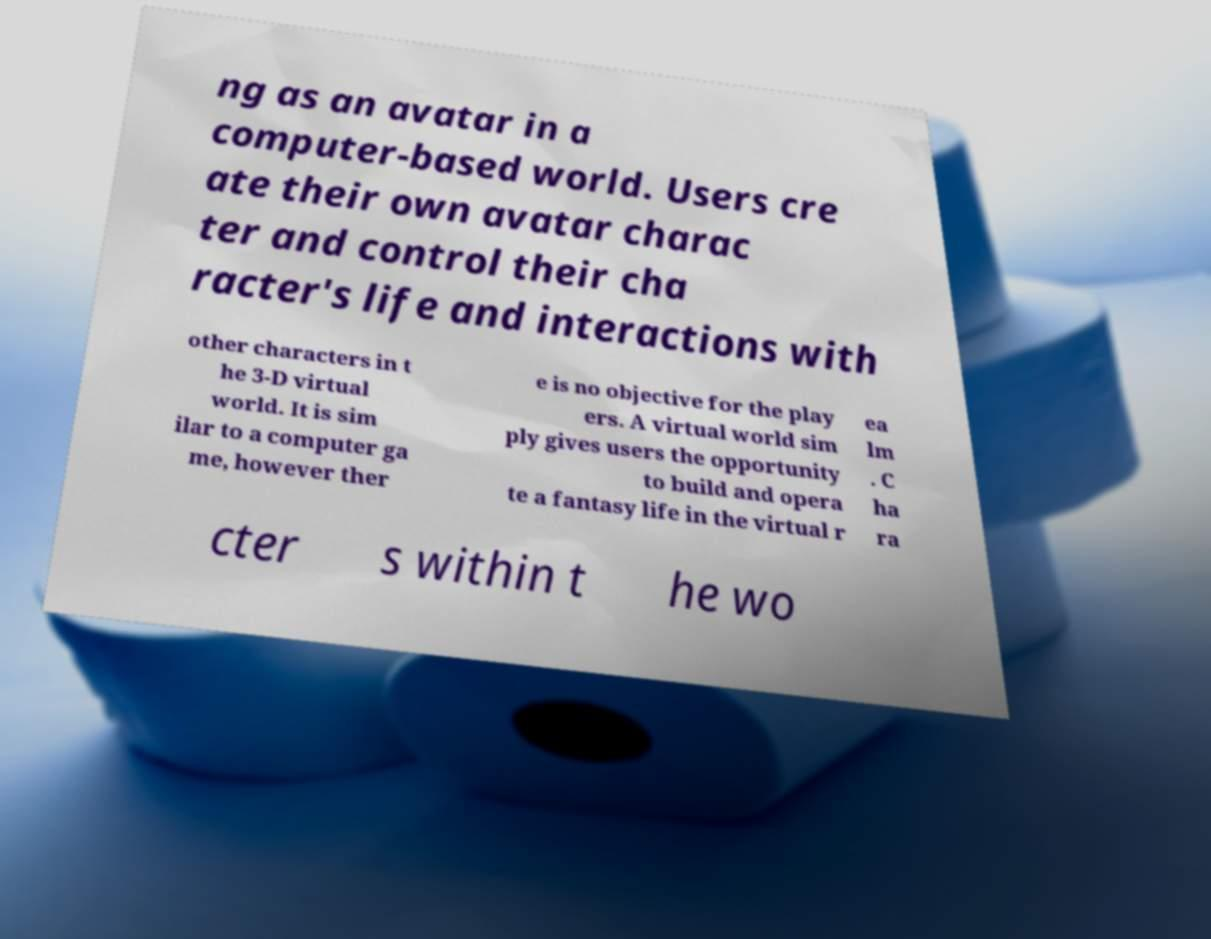Could you extract and type out the text from this image? ng as an avatar in a computer-based world. Users cre ate their own avatar charac ter and control their cha racter's life and interactions with other characters in t he 3-D virtual world. It is sim ilar to a computer ga me, however ther e is no objective for the play ers. A virtual world sim ply gives users the opportunity to build and opera te a fantasy life in the virtual r ea lm . C ha ra cter s within t he wo 